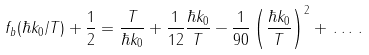<formula> <loc_0><loc_0><loc_500><loc_500>f _ { b } ( \hbar { k } _ { 0 } / T ) + \frac { 1 } { 2 } = \frac { T } { \hbar { k } _ { 0 } } + \frac { 1 } { 1 2 } \frac { \hbar { k } _ { 0 } } { T } - \frac { 1 } { 9 0 } \left ( \frac { \hbar { k } _ { 0 } } { T } \right ) ^ { 2 } + \, \dots \, .</formula> 